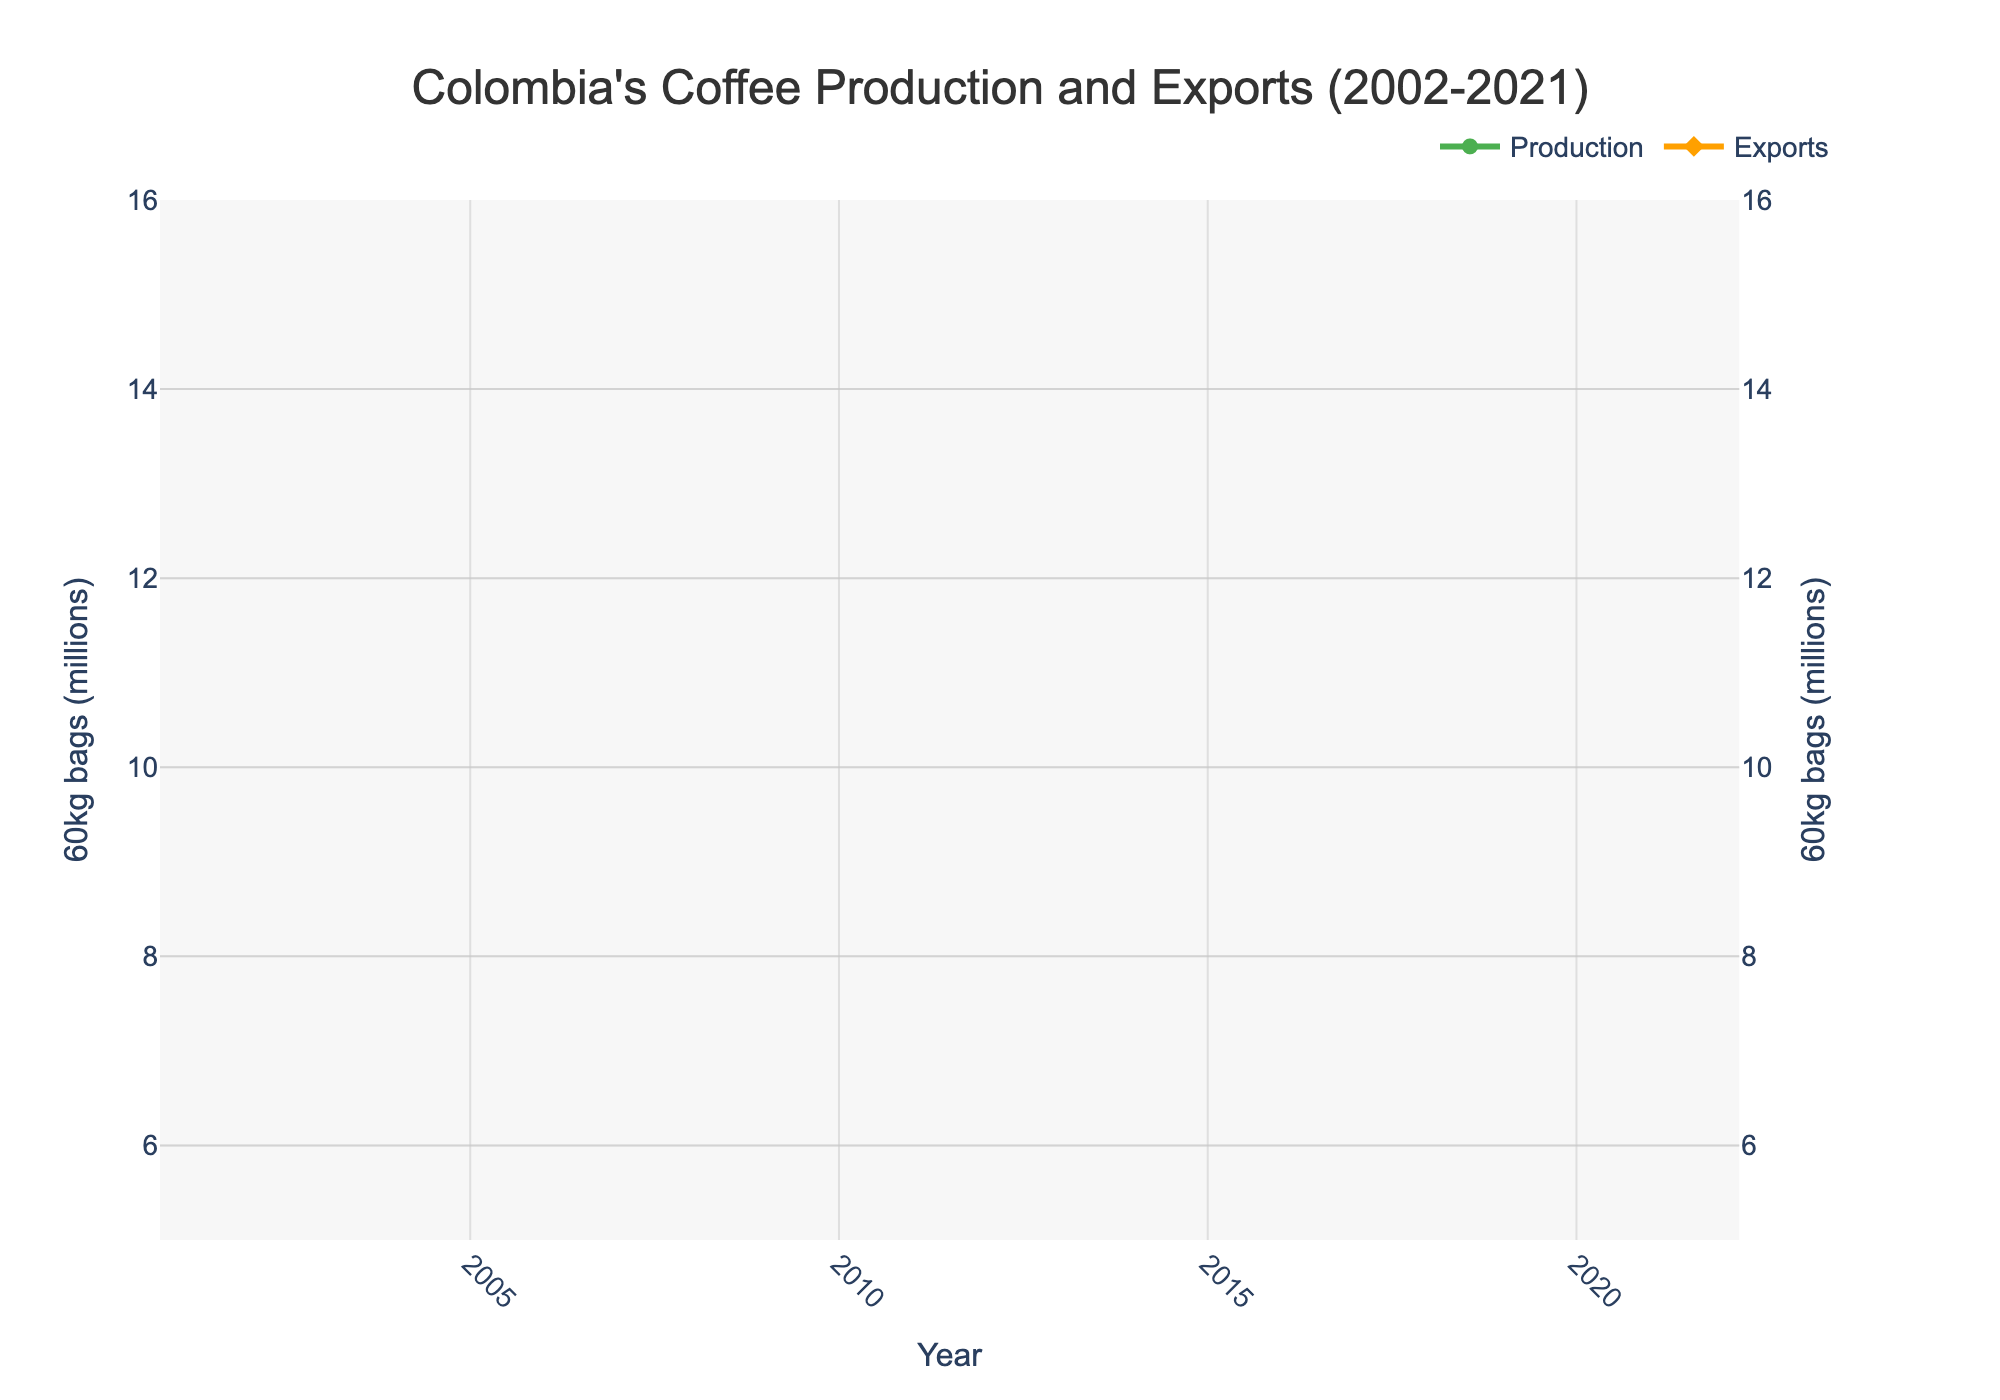How did coffee production and exports in 2021 compare to 2002? Compare production and exports values for 2021 and 2002. Production decreased from 11,700,000 bags in 2002 to 12,580,000 bags in 2021, and exports decreased from 10,274,000 bags in 2002 to 11,346,000 bags in 2021.
Answer: Production increased; Exports increased What year(s) had the lowest production? Look for the lowest point in the Production line. The lowest production was in 2009.
Answer: 2009 What is the difference in export volumes between 2010 and 2011? Subtract the export value of 2011 (7,734,000 bags) from 2010 (7,822,000 bags). The difference is 7,822,000 - 7,734,000 = 88,000 bags.
Answer: 88,000 bags Identify the years where exports exceeded production. Compare Production and Exports lines. Exports exceeded production in 2008 (11,085,000 vs. 8,664,000 bags), 2009 (7,894,000 vs. 8,098,000 bags), and 2010 (7,822,000 vs. 8,523,000 bags).
Answer: 2008, 2009, 2010 In which year did coffee production peak? Identify the highest point in the Production line. The peak production was in 2019 with 14,800,000 bags.
Answer: 2019 What trend can you observe in the exports volume from 2002 to 2021? Analyze the pattern of the Exports line over the period. Initially, the exports were fairly stable, with fluctuations, showed a decline in the early 2010s, peaked around 2017-2019, and then dropped slightly towards 2021.
Answer: Fluctuating, peak around 2017-2019 How significant was the drop in production between 2007 and 2009? Calculate the difference between production in 2007 (12,515,000 bags) and 2009 (8,098,000 bags). The drop was 12,515,000 - 8,098,000 = 4,417,000 bags.
Answer: 4,417,000 bags What is the average production during the period of 2002-2021? Sum all production values and divide by the number of years (20 years). Average production = (11700000 + 11600000 + 12033000 + 11527000 + 12153000 + 12515000 + 8664000 + 8098000 + 8523000 + 7809000 + 9927000 + 12163000 + 13333000 + 14009000 + 14234000 + 14000000 + 13858000 + 14800000 + 13904000 + 12580000) / 20. Average production = 12,017,650 bags.
Answer: 12,017,650 bags Did production and exports ever diverge significantly? Look for years where there's a noticeable gap between Production and Exports lines. There is a significant divergence in 2008, where production was 8,664,000 bags and exports were 11,085,000 bags.
Answer: 2008 Which color represents coffee export volumes in the chart? Identify the color associated with the Exports line. The Exports line is represented in orange color.
Answer: Orange 